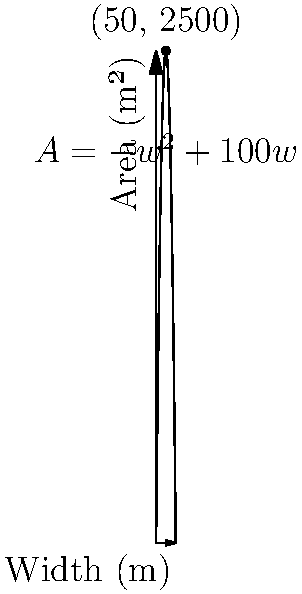As a wildlife veterinarian, you're tasked with designing a rectangular enclosure for rehabilitating injured animals. The enclosure will be built against an existing straight fence, which will form one of the long sides. If you have 200 meters of fencing material available for the remaining three sides, how should you dimension the enclosure to maximize its area? Use the quadratic function $A(w) = -w^2 + 100w$, where $A$ is the area in square meters and $w$ is the width in meters. To find the maximum area, we need to follow these steps:

1) The given quadratic function is $A(w) = -w^2 + 100w$.

2) To find the maximum point of a quadratic function, we can use the vertex formula: $w = -\frac{b}{2a}$, where $a$ and $b$ are the coefficients of the quadratic function in standard form $(aw^2 + bw + c)$.

3) In this case, $a = -1$ and $b = 100$.

4) Plugging into the vertex formula:
   $w = -\frac{100}{2(-1)} = 50$ meters

5) To find the maximum area, we substitute this width back into the original function:
   $A(50) = -(50)^2 + 100(50) = -2500 + 5000 = 2500$ square meters

6) Therefore, the enclosure should be 50 meters wide and 50 meters long (since the total perimeter is 200 meters, and one long side is already provided by the existing fence).

This dimension will provide the maximum possible area of 2500 square meters for the animals' rehabilitation.
Answer: Width: 50 m, Length: 50 m, Maximum Area: 2500 m² 